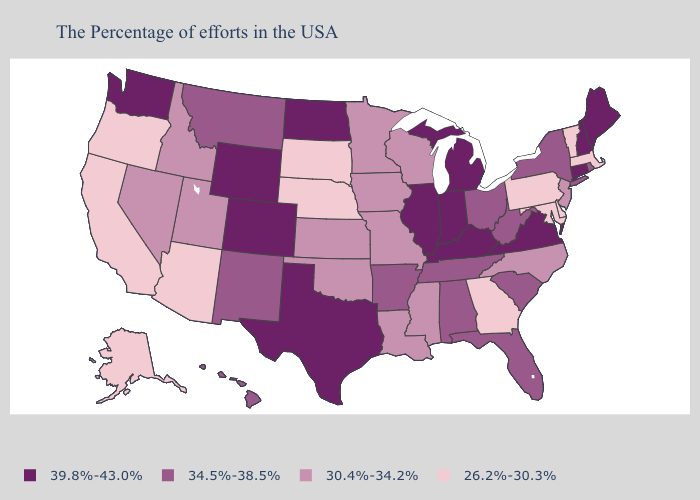Does the map have missing data?
Give a very brief answer. No. Does Indiana have a higher value than Connecticut?
Short answer required. No. Does Idaho have a higher value than Indiana?
Answer briefly. No. Name the states that have a value in the range 30.4%-34.2%?
Answer briefly. New Jersey, North Carolina, Wisconsin, Mississippi, Louisiana, Missouri, Minnesota, Iowa, Kansas, Oklahoma, Utah, Idaho, Nevada. Does North Dakota have the highest value in the USA?
Keep it brief. Yes. What is the lowest value in states that border California?
Be succinct. 26.2%-30.3%. What is the value of Virginia?
Keep it brief. 39.8%-43.0%. What is the highest value in states that border Montana?
Give a very brief answer. 39.8%-43.0%. How many symbols are there in the legend?
Quick response, please. 4. What is the value of Alabama?
Keep it brief. 34.5%-38.5%. Does the map have missing data?
Concise answer only. No. Does Oregon have a lower value than Pennsylvania?
Answer briefly. No. What is the value of Louisiana?
Give a very brief answer. 30.4%-34.2%. What is the lowest value in states that border Missouri?
Keep it brief. 26.2%-30.3%. 